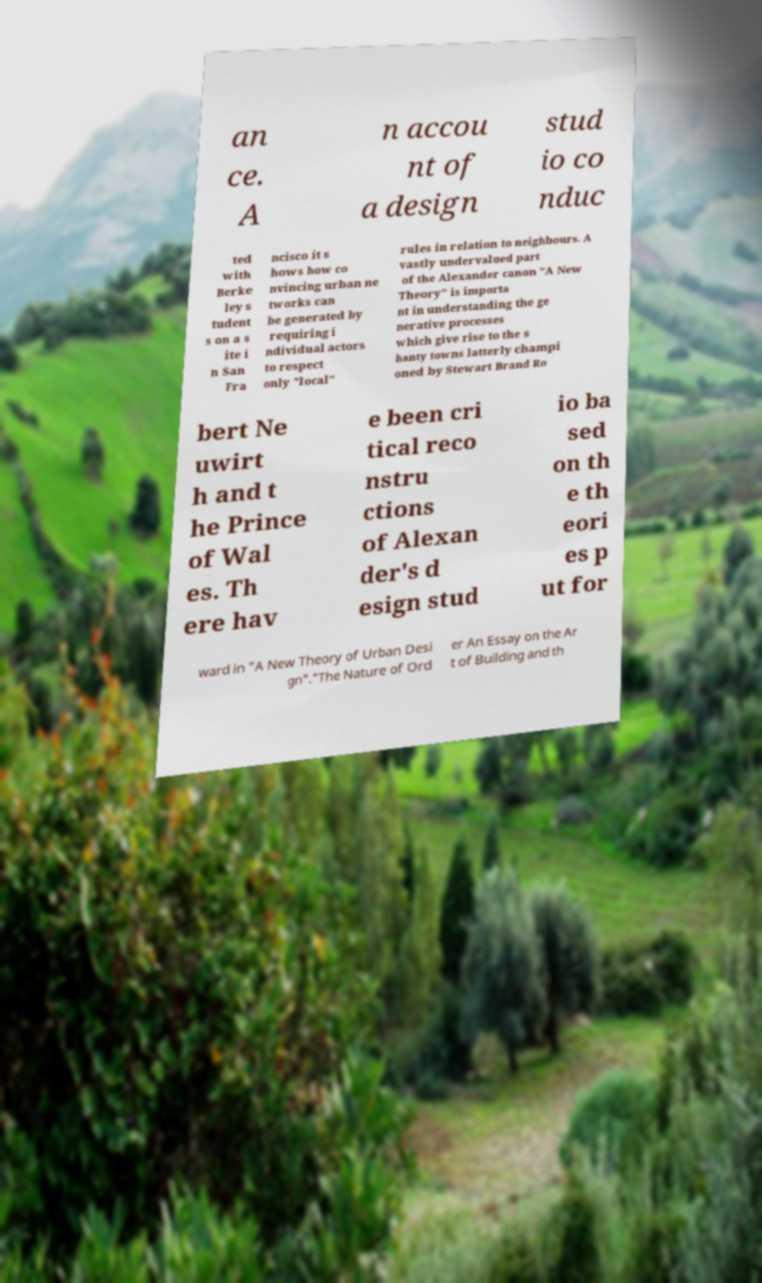There's text embedded in this image that I need extracted. Can you transcribe it verbatim? an ce. A n accou nt of a design stud io co nduc ted with Berke ley s tudent s on a s ite i n San Fra ncisco it s hows how co nvincing urban ne tworks can be generated by requiring i ndividual actors to respect only "local" rules in relation to neighbours. A vastly undervalued part of the Alexander canon "A New Theory" is importa nt in understanding the ge nerative processes which give rise to the s hanty towns latterly champi oned by Stewart Brand Ro bert Ne uwirt h and t he Prince of Wal es. Th ere hav e been cri tical reco nstru ctions of Alexan der's d esign stud io ba sed on th e th eori es p ut for ward in "A New Theory of Urban Desi gn"."The Nature of Ord er An Essay on the Ar t of Building and th 